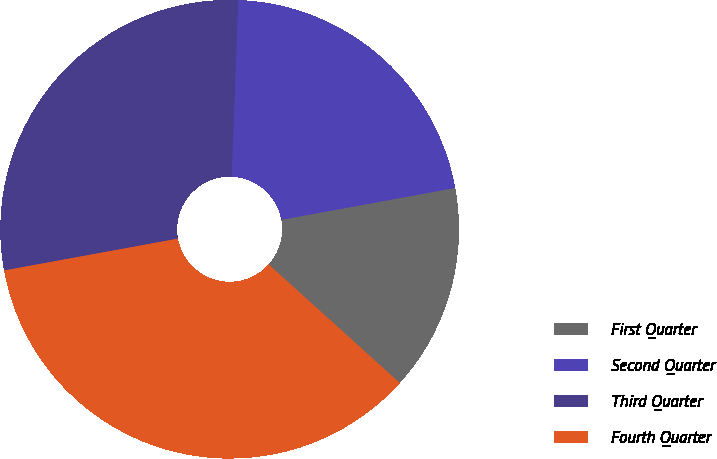Convert chart. <chart><loc_0><loc_0><loc_500><loc_500><pie_chart><fcel>First Quarter<fcel>Second Quarter<fcel>Third Quarter<fcel>Fourth Quarter<nl><fcel>14.58%<fcel>21.53%<fcel>28.47%<fcel>35.42%<nl></chart> 